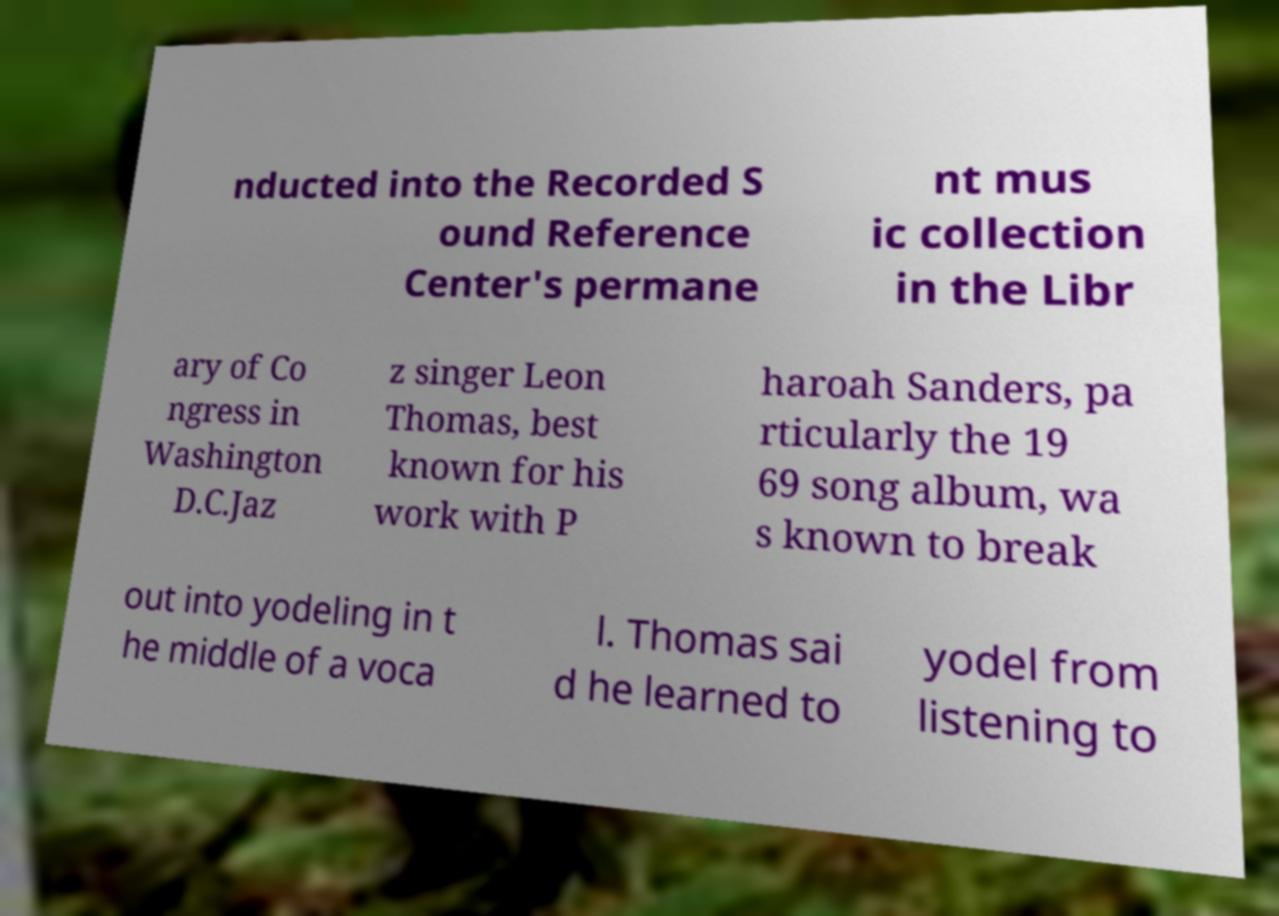For documentation purposes, I need the text within this image transcribed. Could you provide that? nducted into the Recorded S ound Reference Center's permane nt mus ic collection in the Libr ary of Co ngress in Washington D.C.Jaz z singer Leon Thomas, best known for his work with P haroah Sanders, pa rticularly the 19 69 song album, wa s known to break out into yodeling in t he middle of a voca l. Thomas sai d he learned to yodel from listening to 